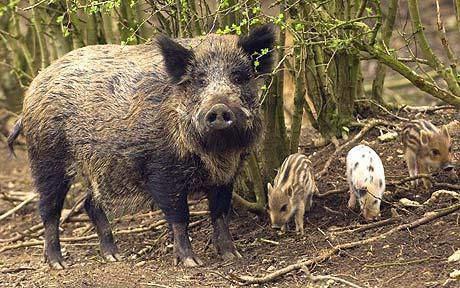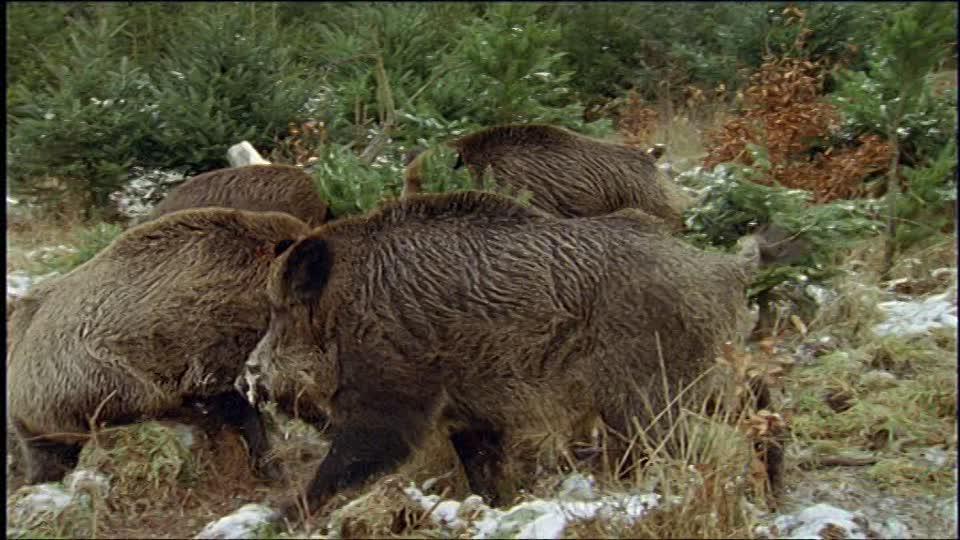The first image is the image on the left, the second image is the image on the right. For the images displayed, is the sentence "there is one hog on the right image standing" factually correct? Answer yes or no. No. 